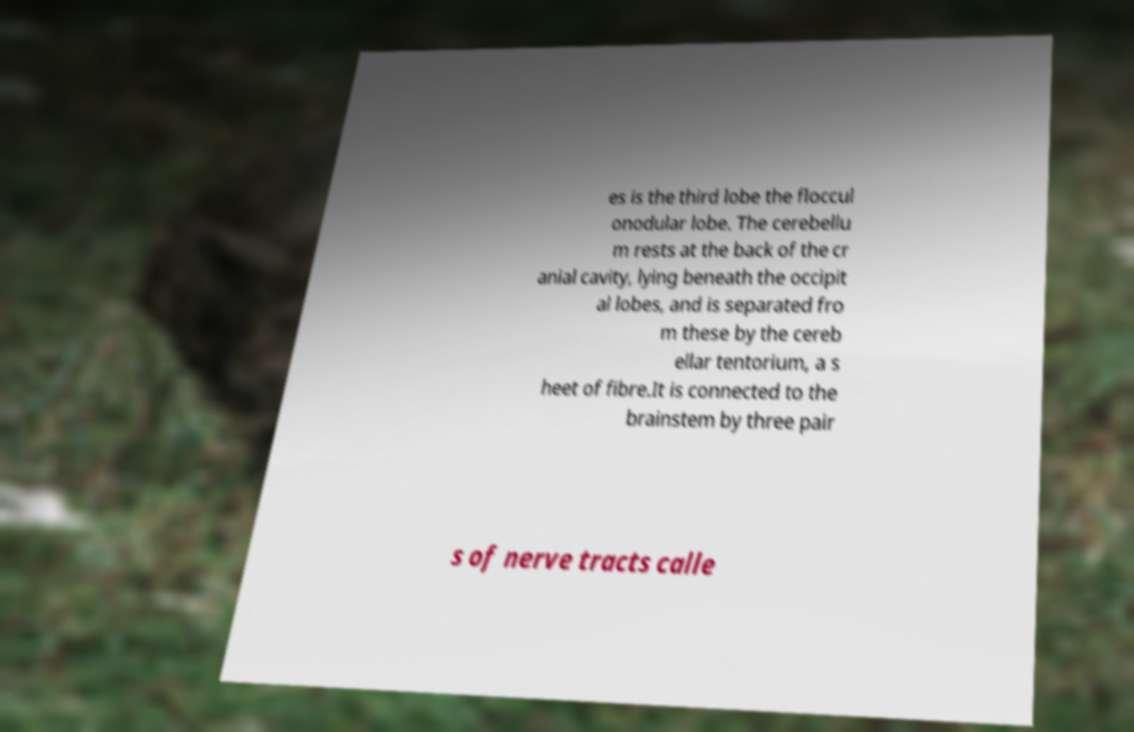For documentation purposes, I need the text within this image transcribed. Could you provide that? es is the third lobe the floccul onodular lobe. The cerebellu m rests at the back of the cr anial cavity, lying beneath the occipit al lobes, and is separated fro m these by the cereb ellar tentorium, a s heet of fibre.It is connected to the brainstem by three pair s of nerve tracts calle 